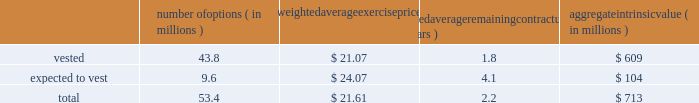Intel corporation notes to consolidated financial statements ( continued ) the aggregate fair value of awards that vested in 2015 was $ 1.5 billion ( $ 1.1 billion in 2014 and $ 1.0 billion in 2013 ) , which represents the market value of our common stock on the date that the rsus vested .
The grant-date fair value of awards that vested in 2015 was $ 1.1 billion ( $ 949 million in 2014 and $ 899 million in 2013 ) .
The number of rsus vested includes shares of common stock that we withheld on behalf of employees to satisfy the minimum statutory tax withholding requirements .
Rsus that are expected to vest are net of estimated future forfeitures .
As of december 26 , 2015 , there was $ 1.8 billion in unrecognized compensation costs related to rsus granted under our equity incentive plans .
We expect to recognize those costs over a weighted average period of 1.2 years .
Stock option awards as of december 26 , 2015 , options outstanding that have vested and are expected to vest were as follows : number of options ( in millions ) weighted average exercise weighted average remaining contractual ( in years ) aggregate intrinsic ( in millions ) .
Aggregate intrinsic value represents the difference between the exercise price and $ 34.98 , the closing price of our common stock on december 24 , 2015 , as reported on the nasdaq global select market , for all in-the-money options outstanding .
Options outstanding that are expected to vest are net of estimated future option forfeitures .
Options with a fair value of $ 42 million completed vesting in 2015 ( $ 68 million in 2014 and $ 186 million in 2013 ) .
As of december 26 , 2015 , there was $ 13 million in unrecognized compensation costs related to stock options granted under our equity incentive plans .
We expect to recognize those costs over a weighted average period of approximately eight months. .
What percentage of stock option awards are expected to vest as of december 26 , 2015? 
Computations: (9.6 / 53.4)
Answer: 0.17978. 